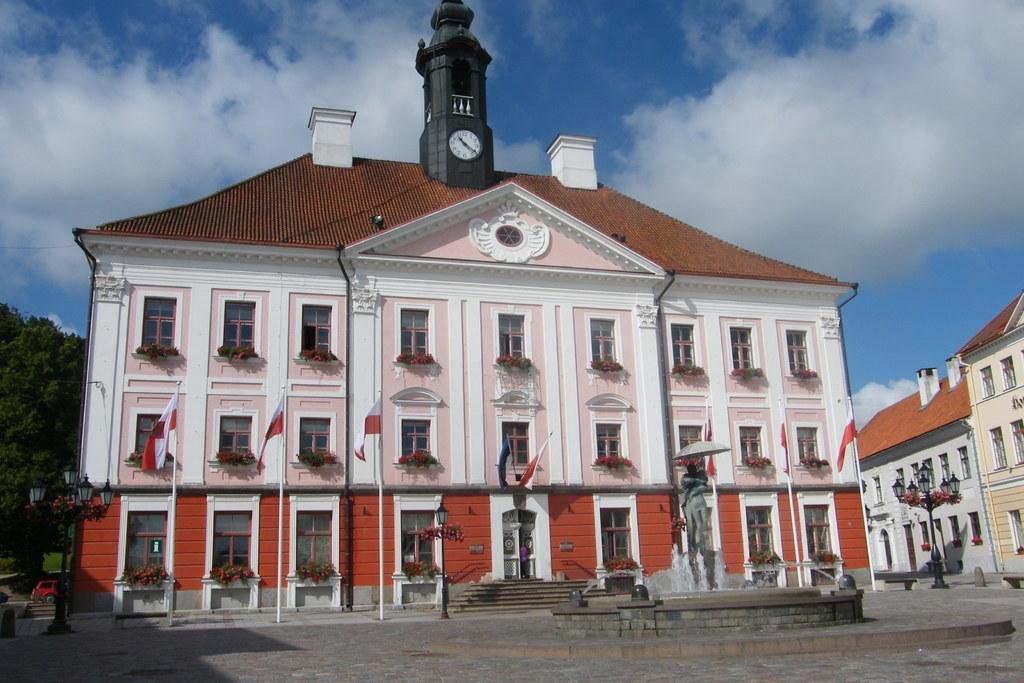What type of structures can be seen in the image? There are buildings in the image. What is located in front of the buildings? There is a sculpture and a water fountain in front of the buildings. What can be used for illumination in the image? There are light poles in the image. What is visible at the top of the image? The sky is visible at the top of the image. What type of vegetation is on the right side of the image? There is a tree on the right side of the image. Can you tell me how many hearts are depicted on the sculpture in the image? There is no mention of hearts or any heart-shaped objects on the sculpture in the image. What type of pet can be seen playing with the water fountain in the image? There is no pet present in the image; it features a sculpture, buildings, and a water fountain. 